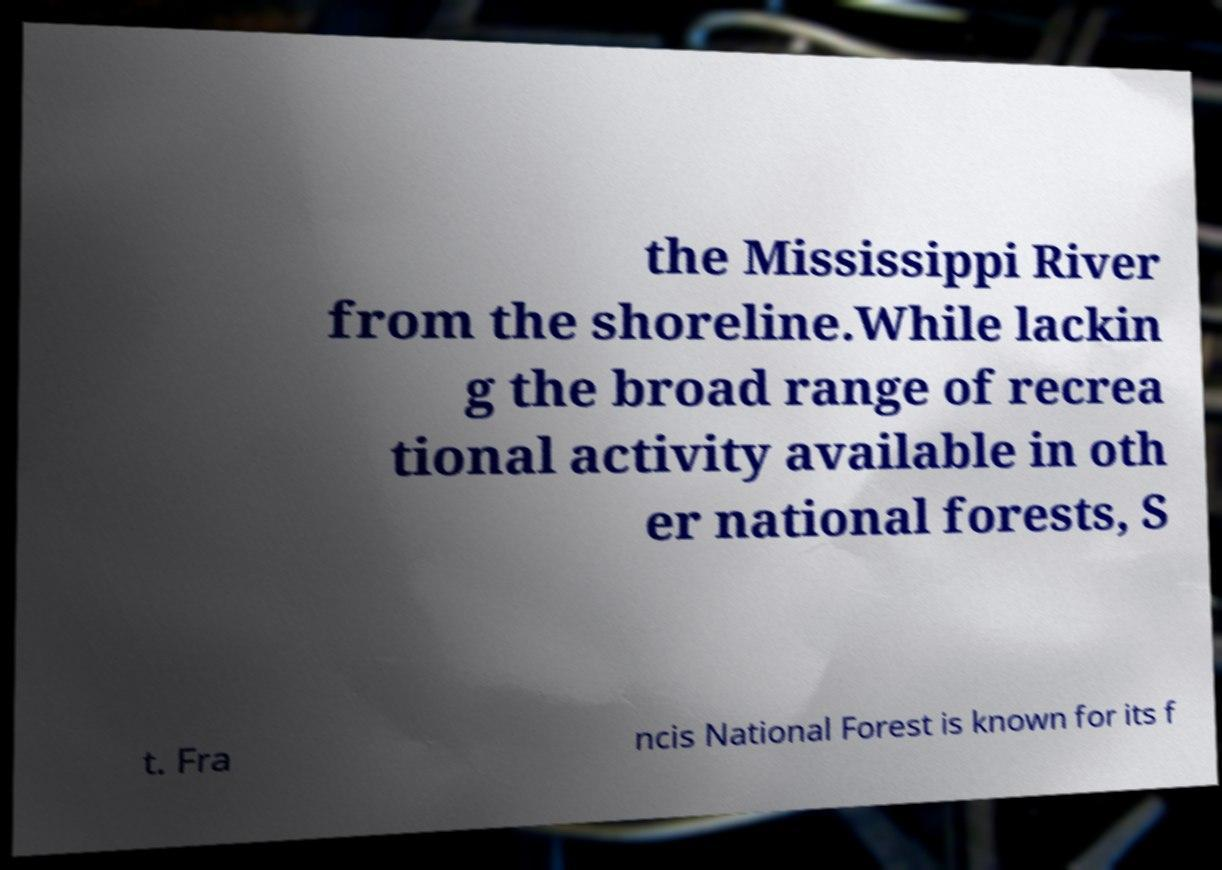What messages or text are displayed in this image? I need them in a readable, typed format. the Mississippi River from the shoreline.While lackin g the broad range of recrea tional activity available in oth er national forests, S t. Fra ncis National Forest is known for its f 